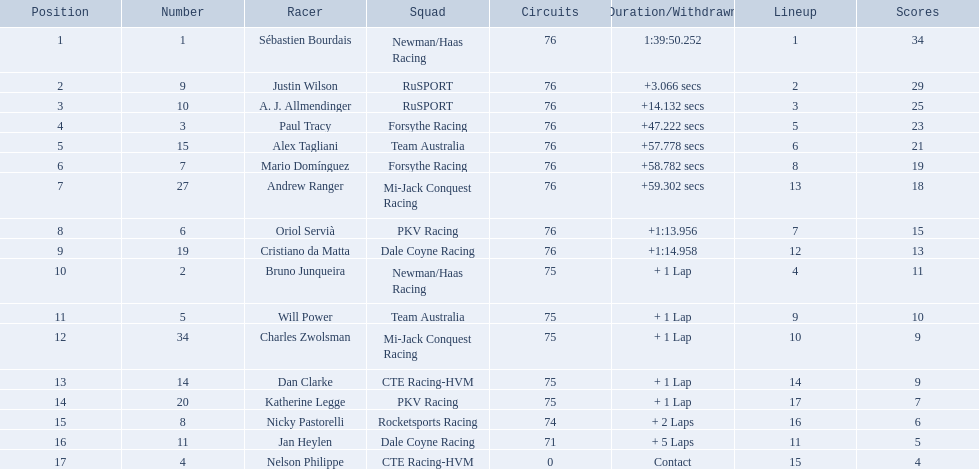How many points did charles zwolsman acquire? 9. Who else got 9 points? Dan Clarke. 